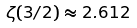<formula> <loc_0><loc_0><loc_500><loc_500>\zeta ( 3 / 2 ) \approx 2 . 6 1 2</formula> 